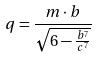<formula> <loc_0><loc_0><loc_500><loc_500>q = \frac { m \cdot b } { \sqrt { 6 - \frac { b ^ { 7 } } { c ^ { 7 } } } }</formula> 